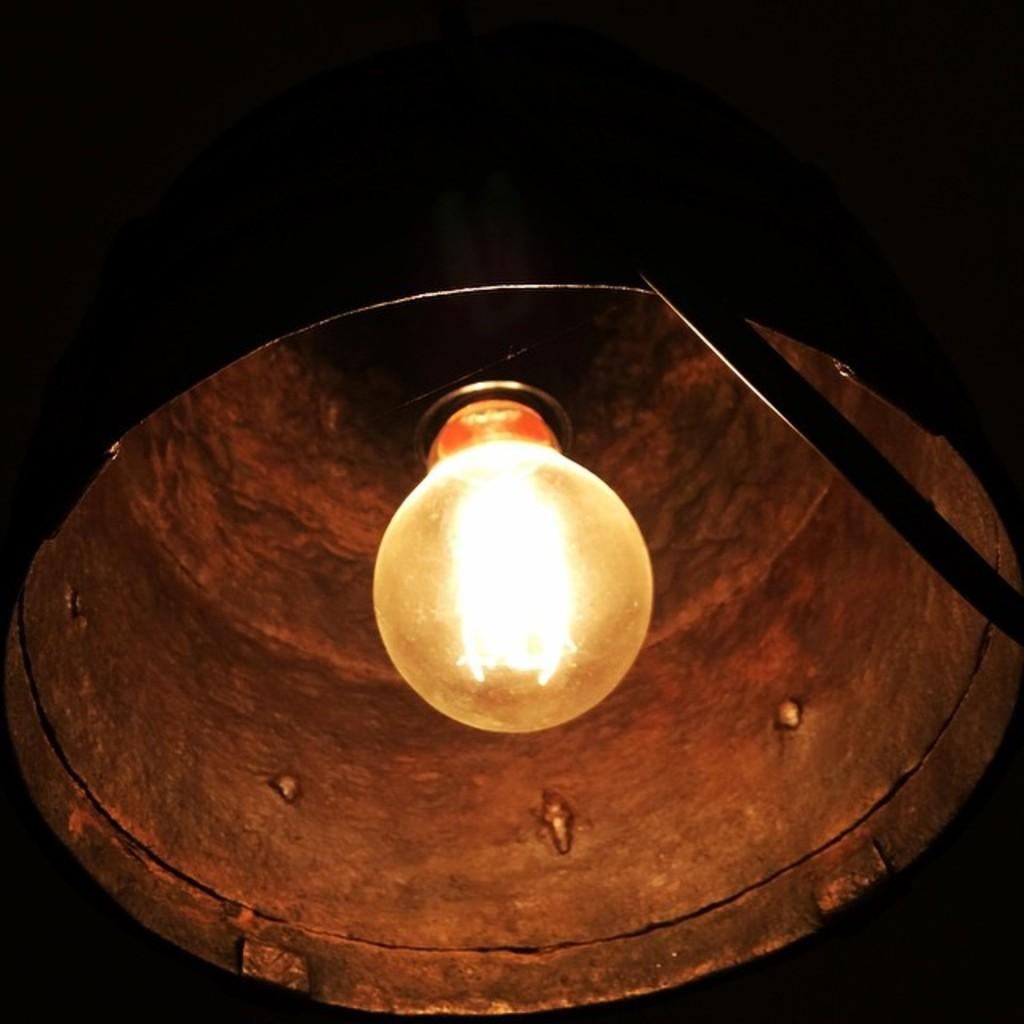What object is present in the image that provides light? There is a lamp in the image. What can be said about the overall lighting in the image? The background of the image is dark. What type of love can be seen expressed between the jellyfish in the image? There are no jellyfish present in the image, so it is not possible to determine any type of love being expressed. 